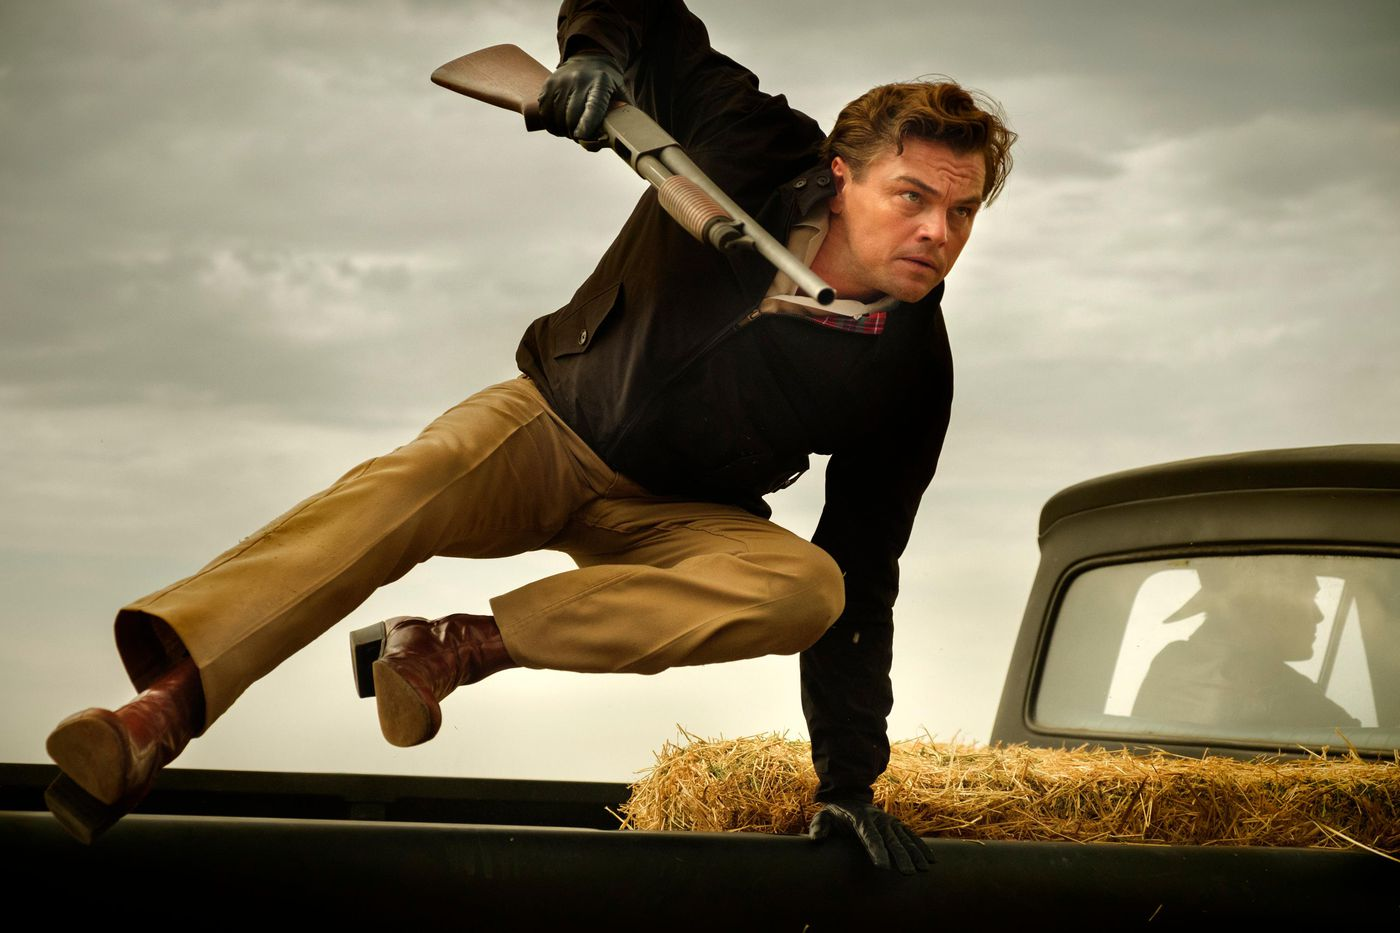Explore the style and time period indicated by the clothing and props in this image. The clothing and props in the image suggest a setting that blends modern and vintage elements. The man's outfit, particularly his black jacket and plaid shirt, along with his tan pants and leather boots, evoke a rugged, timeless style. The black vintage car, possibly from the mid-20th century, complements this aesthetic, providing a backdrop that adds an old-fashioned charm to the scene. 